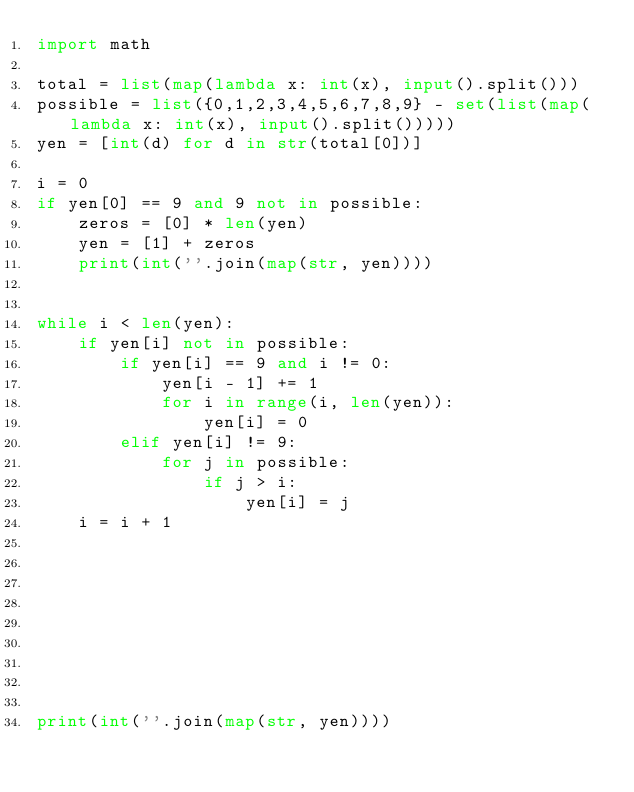Convert code to text. <code><loc_0><loc_0><loc_500><loc_500><_Python_>import math

total = list(map(lambda x: int(x), input().split()))
possible = list({0,1,2,3,4,5,6,7,8,9} - set(list(map(lambda x: int(x), input().split()))))
yen = [int(d) for d in str(total[0])]

i = 0
if yen[0] == 9 and 9 not in possible:
    zeros = [0] * len(yen)
    yen = [1] + zeros
    print(int(''.join(map(str, yen))))


while i < len(yen):
    if yen[i] not in possible:
        if yen[i] == 9 and i != 0:
            yen[i - 1] += 1
            for i in range(i, len(yen)):
                yen[i] = 0
        elif yen[i] != 9:
            for j in possible:
                if j > i:
                    yen[i] = j
    i = i + 1
        
                
                
            
            




print(int(''.join(map(str, yen))))
        

        
                
        
        
    

    
    

</code> 